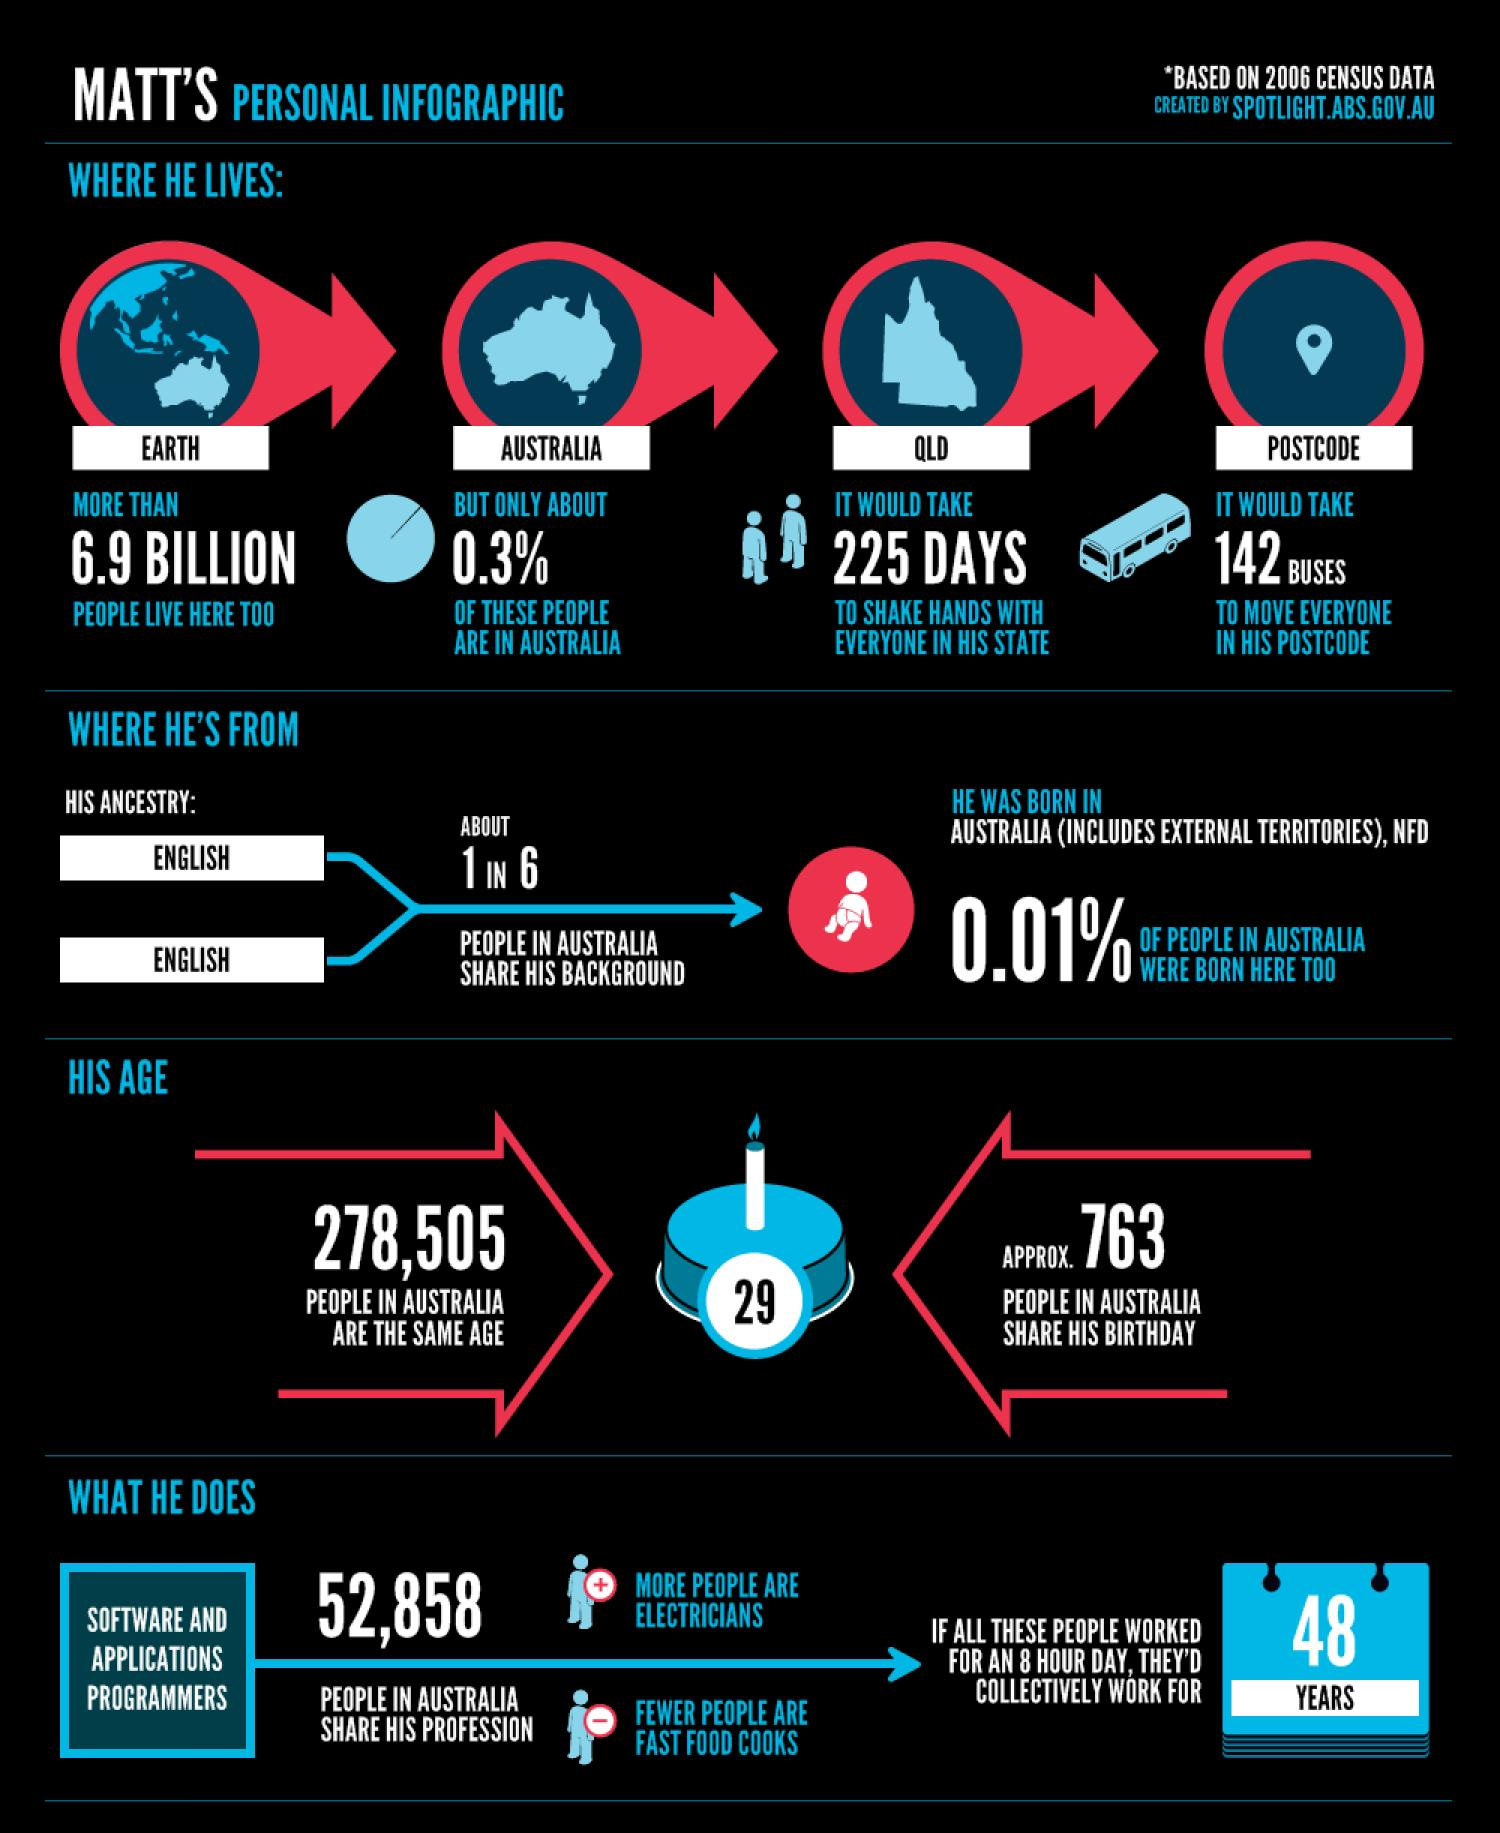Identify some key points in this picture. Matt is 29 years old. It will take Matt 225 days to shake hands with every person in his state. In Australia, there are 278,505 individuals of the same age as Matt. Approximately 763 people were born on the same day as Matt. It is estimated that approximately 99.7% of the global population resides outside of Australia. 